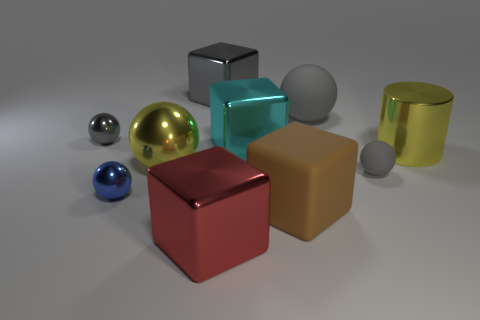Subtract all gray balls. How many were subtracted if there are1gray balls left? 2 Subtract all cyan cylinders. How many gray balls are left? 3 Subtract all cyan spheres. Subtract all yellow blocks. How many spheres are left? 5 Subtract all cylinders. How many objects are left? 9 Subtract all blue metal spheres. Subtract all big yellow metal cylinders. How many objects are left? 8 Add 9 brown rubber blocks. How many brown rubber blocks are left? 10 Add 7 small spheres. How many small spheres exist? 10 Subtract 0 red spheres. How many objects are left? 10 